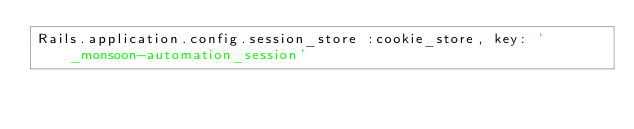Convert code to text. <code><loc_0><loc_0><loc_500><loc_500><_Ruby_>Rails.application.config.session_store :cookie_store, key: '_monsoon-automation_session'
</code> 